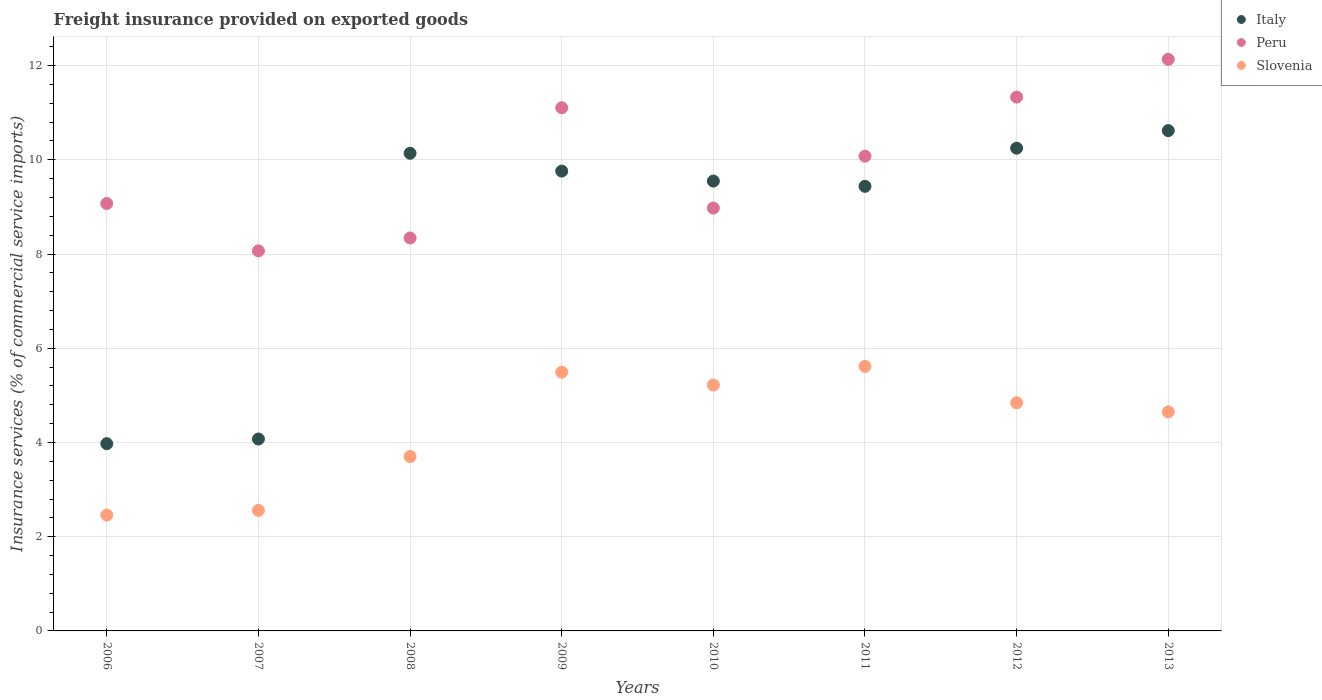Is the number of dotlines equal to the number of legend labels?
Your response must be concise. Yes. What is the freight insurance provided on exported goods in Slovenia in 2011?
Ensure brevity in your answer.  5.61. Across all years, what is the maximum freight insurance provided on exported goods in Slovenia?
Provide a short and direct response. 5.61. Across all years, what is the minimum freight insurance provided on exported goods in Italy?
Give a very brief answer. 3.97. What is the total freight insurance provided on exported goods in Peru in the graph?
Keep it short and to the point. 79.1. What is the difference between the freight insurance provided on exported goods in Italy in 2006 and that in 2009?
Make the answer very short. -5.79. What is the difference between the freight insurance provided on exported goods in Peru in 2006 and the freight insurance provided on exported goods in Italy in 2008?
Your answer should be very brief. -1.07. What is the average freight insurance provided on exported goods in Italy per year?
Provide a succinct answer. 8.47. In the year 2009, what is the difference between the freight insurance provided on exported goods in Peru and freight insurance provided on exported goods in Slovenia?
Give a very brief answer. 5.61. What is the ratio of the freight insurance provided on exported goods in Italy in 2008 to that in 2009?
Your answer should be compact. 1.04. Is the difference between the freight insurance provided on exported goods in Peru in 2008 and 2009 greater than the difference between the freight insurance provided on exported goods in Slovenia in 2008 and 2009?
Make the answer very short. No. What is the difference between the highest and the second highest freight insurance provided on exported goods in Peru?
Keep it short and to the point. 0.8. What is the difference between the highest and the lowest freight insurance provided on exported goods in Slovenia?
Make the answer very short. 3.16. Is the sum of the freight insurance provided on exported goods in Peru in 2008 and 2012 greater than the maximum freight insurance provided on exported goods in Italy across all years?
Keep it short and to the point. Yes. Does the freight insurance provided on exported goods in Slovenia monotonically increase over the years?
Your answer should be very brief. No. What is the difference between two consecutive major ticks on the Y-axis?
Make the answer very short. 2. Are the values on the major ticks of Y-axis written in scientific E-notation?
Provide a short and direct response. No. Does the graph contain any zero values?
Offer a terse response. No. Where does the legend appear in the graph?
Provide a short and direct response. Top right. How many legend labels are there?
Offer a very short reply. 3. What is the title of the graph?
Offer a very short reply. Freight insurance provided on exported goods. What is the label or title of the Y-axis?
Your answer should be very brief. Insurance services (% of commercial service imports). What is the Insurance services (% of commercial service imports) of Italy in 2006?
Make the answer very short. 3.97. What is the Insurance services (% of commercial service imports) of Peru in 2006?
Keep it short and to the point. 9.07. What is the Insurance services (% of commercial service imports) in Slovenia in 2006?
Give a very brief answer. 2.46. What is the Insurance services (% of commercial service imports) of Italy in 2007?
Your response must be concise. 4.07. What is the Insurance services (% of commercial service imports) in Peru in 2007?
Make the answer very short. 8.07. What is the Insurance services (% of commercial service imports) in Slovenia in 2007?
Offer a terse response. 2.56. What is the Insurance services (% of commercial service imports) of Italy in 2008?
Ensure brevity in your answer.  10.14. What is the Insurance services (% of commercial service imports) in Peru in 2008?
Make the answer very short. 8.34. What is the Insurance services (% of commercial service imports) of Slovenia in 2008?
Your answer should be compact. 3.7. What is the Insurance services (% of commercial service imports) in Italy in 2009?
Keep it short and to the point. 9.76. What is the Insurance services (% of commercial service imports) in Peru in 2009?
Keep it short and to the point. 11.1. What is the Insurance services (% of commercial service imports) in Slovenia in 2009?
Your answer should be very brief. 5.49. What is the Insurance services (% of commercial service imports) in Italy in 2010?
Your response must be concise. 9.55. What is the Insurance services (% of commercial service imports) of Peru in 2010?
Your response must be concise. 8.98. What is the Insurance services (% of commercial service imports) in Slovenia in 2010?
Provide a succinct answer. 5.22. What is the Insurance services (% of commercial service imports) in Italy in 2011?
Ensure brevity in your answer.  9.44. What is the Insurance services (% of commercial service imports) of Peru in 2011?
Offer a very short reply. 10.08. What is the Insurance services (% of commercial service imports) of Slovenia in 2011?
Keep it short and to the point. 5.61. What is the Insurance services (% of commercial service imports) of Italy in 2012?
Ensure brevity in your answer.  10.25. What is the Insurance services (% of commercial service imports) of Peru in 2012?
Offer a terse response. 11.33. What is the Insurance services (% of commercial service imports) of Slovenia in 2012?
Your answer should be compact. 4.84. What is the Insurance services (% of commercial service imports) of Italy in 2013?
Your answer should be compact. 10.62. What is the Insurance services (% of commercial service imports) of Peru in 2013?
Your response must be concise. 12.13. What is the Insurance services (% of commercial service imports) in Slovenia in 2013?
Your answer should be compact. 4.65. Across all years, what is the maximum Insurance services (% of commercial service imports) of Italy?
Your answer should be very brief. 10.62. Across all years, what is the maximum Insurance services (% of commercial service imports) in Peru?
Your response must be concise. 12.13. Across all years, what is the maximum Insurance services (% of commercial service imports) of Slovenia?
Provide a short and direct response. 5.61. Across all years, what is the minimum Insurance services (% of commercial service imports) of Italy?
Your response must be concise. 3.97. Across all years, what is the minimum Insurance services (% of commercial service imports) in Peru?
Give a very brief answer. 8.07. Across all years, what is the minimum Insurance services (% of commercial service imports) of Slovenia?
Provide a succinct answer. 2.46. What is the total Insurance services (% of commercial service imports) of Italy in the graph?
Offer a terse response. 67.8. What is the total Insurance services (% of commercial service imports) of Peru in the graph?
Ensure brevity in your answer.  79.1. What is the total Insurance services (% of commercial service imports) of Slovenia in the graph?
Your answer should be compact. 34.54. What is the difference between the Insurance services (% of commercial service imports) in Italy in 2006 and that in 2007?
Your answer should be compact. -0.1. What is the difference between the Insurance services (% of commercial service imports) in Peru in 2006 and that in 2007?
Your response must be concise. 1.01. What is the difference between the Insurance services (% of commercial service imports) in Slovenia in 2006 and that in 2007?
Your answer should be very brief. -0.1. What is the difference between the Insurance services (% of commercial service imports) of Italy in 2006 and that in 2008?
Ensure brevity in your answer.  -6.16. What is the difference between the Insurance services (% of commercial service imports) in Peru in 2006 and that in 2008?
Your answer should be compact. 0.73. What is the difference between the Insurance services (% of commercial service imports) of Slovenia in 2006 and that in 2008?
Your response must be concise. -1.24. What is the difference between the Insurance services (% of commercial service imports) in Italy in 2006 and that in 2009?
Provide a short and direct response. -5.79. What is the difference between the Insurance services (% of commercial service imports) in Peru in 2006 and that in 2009?
Give a very brief answer. -2.03. What is the difference between the Insurance services (% of commercial service imports) in Slovenia in 2006 and that in 2009?
Provide a short and direct response. -3.03. What is the difference between the Insurance services (% of commercial service imports) in Italy in 2006 and that in 2010?
Ensure brevity in your answer.  -5.57. What is the difference between the Insurance services (% of commercial service imports) in Peru in 2006 and that in 2010?
Provide a succinct answer. 0.1. What is the difference between the Insurance services (% of commercial service imports) in Slovenia in 2006 and that in 2010?
Your answer should be compact. -2.76. What is the difference between the Insurance services (% of commercial service imports) in Italy in 2006 and that in 2011?
Your answer should be compact. -5.46. What is the difference between the Insurance services (% of commercial service imports) of Peru in 2006 and that in 2011?
Provide a short and direct response. -1. What is the difference between the Insurance services (% of commercial service imports) of Slovenia in 2006 and that in 2011?
Ensure brevity in your answer.  -3.16. What is the difference between the Insurance services (% of commercial service imports) in Italy in 2006 and that in 2012?
Offer a terse response. -6.27. What is the difference between the Insurance services (% of commercial service imports) in Peru in 2006 and that in 2012?
Your answer should be very brief. -2.26. What is the difference between the Insurance services (% of commercial service imports) of Slovenia in 2006 and that in 2012?
Ensure brevity in your answer.  -2.38. What is the difference between the Insurance services (% of commercial service imports) of Italy in 2006 and that in 2013?
Your response must be concise. -6.65. What is the difference between the Insurance services (% of commercial service imports) in Peru in 2006 and that in 2013?
Make the answer very short. -3.06. What is the difference between the Insurance services (% of commercial service imports) in Slovenia in 2006 and that in 2013?
Your answer should be compact. -2.19. What is the difference between the Insurance services (% of commercial service imports) of Italy in 2007 and that in 2008?
Ensure brevity in your answer.  -6.07. What is the difference between the Insurance services (% of commercial service imports) of Peru in 2007 and that in 2008?
Your response must be concise. -0.27. What is the difference between the Insurance services (% of commercial service imports) of Slovenia in 2007 and that in 2008?
Your response must be concise. -1.14. What is the difference between the Insurance services (% of commercial service imports) in Italy in 2007 and that in 2009?
Make the answer very short. -5.69. What is the difference between the Insurance services (% of commercial service imports) of Peru in 2007 and that in 2009?
Your answer should be very brief. -3.04. What is the difference between the Insurance services (% of commercial service imports) of Slovenia in 2007 and that in 2009?
Your answer should be very brief. -2.93. What is the difference between the Insurance services (% of commercial service imports) of Italy in 2007 and that in 2010?
Make the answer very short. -5.48. What is the difference between the Insurance services (% of commercial service imports) of Peru in 2007 and that in 2010?
Provide a succinct answer. -0.91. What is the difference between the Insurance services (% of commercial service imports) in Slovenia in 2007 and that in 2010?
Provide a succinct answer. -2.66. What is the difference between the Insurance services (% of commercial service imports) in Italy in 2007 and that in 2011?
Your answer should be very brief. -5.36. What is the difference between the Insurance services (% of commercial service imports) of Peru in 2007 and that in 2011?
Keep it short and to the point. -2.01. What is the difference between the Insurance services (% of commercial service imports) of Slovenia in 2007 and that in 2011?
Your response must be concise. -3.05. What is the difference between the Insurance services (% of commercial service imports) of Italy in 2007 and that in 2012?
Keep it short and to the point. -6.17. What is the difference between the Insurance services (% of commercial service imports) in Peru in 2007 and that in 2012?
Your answer should be very brief. -3.26. What is the difference between the Insurance services (% of commercial service imports) of Slovenia in 2007 and that in 2012?
Provide a succinct answer. -2.28. What is the difference between the Insurance services (% of commercial service imports) in Italy in 2007 and that in 2013?
Provide a short and direct response. -6.55. What is the difference between the Insurance services (% of commercial service imports) in Peru in 2007 and that in 2013?
Keep it short and to the point. -4.07. What is the difference between the Insurance services (% of commercial service imports) of Slovenia in 2007 and that in 2013?
Make the answer very short. -2.09. What is the difference between the Insurance services (% of commercial service imports) in Italy in 2008 and that in 2009?
Make the answer very short. 0.38. What is the difference between the Insurance services (% of commercial service imports) in Peru in 2008 and that in 2009?
Provide a succinct answer. -2.76. What is the difference between the Insurance services (% of commercial service imports) of Slovenia in 2008 and that in 2009?
Provide a succinct answer. -1.79. What is the difference between the Insurance services (% of commercial service imports) of Italy in 2008 and that in 2010?
Ensure brevity in your answer.  0.59. What is the difference between the Insurance services (% of commercial service imports) of Peru in 2008 and that in 2010?
Ensure brevity in your answer.  -0.63. What is the difference between the Insurance services (% of commercial service imports) of Slovenia in 2008 and that in 2010?
Provide a short and direct response. -1.52. What is the difference between the Insurance services (% of commercial service imports) in Italy in 2008 and that in 2011?
Ensure brevity in your answer.  0.7. What is the difference between the Insurance services (% of commercial service imports) in Peru in 2008 and that in 2011?
Make the answer very short. -1.74. What is the difference between the Insurance services (% of commercial service imports) of Slovenia in 2008 and that in 2011?
Your response must be concise. -1.91. What is the difference between the Insurance services (% of commercial service imports) of Italy in 2008 and that in 2012?
Provide a succinct answer. -0.11. What is the difference between the Insurance services (% of commercial service imports) in Peru in 2008 and that in 2012?
Provide a succinct answer. -2.99. What is the difference between the Insurance services (% of commercial service imports) of Slovenia in 2008 and that in 2012?
Your response must be concise. -1.14. What is the difference between the Insurance services (% of commercial service imports) in Italy in 2008 and that in 2013?
Your response must be concise. -0.48. What is the difference between the Insurance services (% of commercial service imports) of Peru in 2008 and that in 2013?
Offer a very short reply. -3.79. What is the difference between the Insurance services (% of commercial service imports) of Slovenia in 2008 and that in 2013?
Offer a very short reply. -0.95. What is the difference between the Insurance services (% of commercial service imports) of Italy in 2009 and that in 2010?
Ensure brevity in your answer.  0.21. What is the difference between the Insurance services (% of commercial service imports) of Peru in 2009 and that in 2010?
Your answer should be very brief. 2.13. What is the difference between the Insurance services (% of commercial service imports) in Slovenia in 2009 and that in 2010?
Offer a very short reply. 0.27. What is the difference between the Insurance services (% of commercial service imports) in Italy in 2009 and that in 2011?
Make the answer very short. 0.32. What is the difference between the Insurance services (% of commercial service imports) in Peru in 2009 and that in 2011?
Ensure brevity in your answer.  1.03. What is the difference between the Insurance services (% of commercial service imports) in Slovenia in 2009 and that in 2011?
Your answer should be compact. -0.12. What is the difference between the Insurance services (% of commercial service imports) of Italy in 2009 and that in 2012?
Give a very brief answer. -0.49. What is the difference between the Insurance services (% of commercial service imports) in Peru in 2009 and that in 2012?
Your answer should be very brief. -0.23. What is the difference between the Insurance services (% of commercial service imports) in Slovenia in 2009 and that in 2012?
Your response must be concise. 0.65. What is the difference between the Insurance services (% of commercial service imports) of Italy in 2009 and that in 2013?
Keep it short and to the point. -0.86. What is the difference between the Insurance services (% of commercial service imports) of Peru in 2009 and that in 2013?
Your answer should be compact. -1.03. What is the difference between the Insurance services (% of commercial service imports) in Slovenia in 2009 and that in 2013?
Make the answer very short. 0.84. What is the difference between the Insurance services (% of commercial service imports) in Italy in 2010 and that in 2011?
Provide a succinct answer. 0.11. What is the difference between the Insurance services (% of commercial service imports) in Peru in 2010 and that in 2011?
Provide a succinct answer. -1.1. What is the difference between the Insurance services (% of commercial service imports) in Slovenia in 2010 and that in 2011?
Offer a terse response. -0.4. What is the difference between the Insurance services (% of commercial service imports) of Italy in 2010 and that in 2012?
Give a very brief answer. -0.7. What is the difference between the Insurance services (% of commercial service imports) of Peru in 2010 and that in 2012?
Provide a succinct answer. -2.36. What is the difference between the Insurance services (% of commercial service imports) of Slovenia in 2010 and that in 2012?
Offer a very short reply. 0.37. What is the difference between the Insurance services (% of commercial service imports) of Italy in 2010 and that in 2013?
Keep it short and to the point. -1.07. What is the difference between the Insurance services (% of commercial service imports) of Peru in 2010 and that in 2013?
Your answer should be very brief. -3.16. What is the difference between the Insurance services (% of commercial service imports) in Slovenia in 2010 and that in 2013?
Provide a succinct answer. 0.57. What is the difference between the Insurance services (% of commercial service imports) in Italy in 2011 and that in 2012?
Keep it short and to the point. -0.81. What is the difference between the Insurance services (% of commercial service imports) in Peru in 2011 and that in 2012?
Provide a succinct answer. -1.25. What is the difference between the Insurance services (% of commercial service imports) in Slovenia in 2011 and that in 2012?
Provide a succinct answer. 0.77. What is the difference between the Insurance services (% of commercial service imports) in Italy in 2011 and that in 2013?
Make the answer very short. -1.18. What is the difference between the Insurance services (% of commercial service imports) in Peru in 2011 and that in 2013?
Ensure brevity in your answer.  -2.06. What is the difference between the Insurance services (% of commercial service imports) of Slovenia in 2011 and that in 2013?
Ensure brevity in your answer.  0.96. What is the difference between the Insurance services (% of commercial service imports) in Italy in 2012 and that in 2013?
Provide a succinct answer. -0.37. What is the difference between the Insurance services (% of commercial service imports) in Peru in 2012 and that in 2013?
Your answer should be very brief. -0.8. What is the difference between the Insurance services (% of commercial service imports) of Slovenia in 2012 and that in 2013?
Offer a very short reply. 0.19. What is the difference between the Insurance services (% of commercial service imports) in Italy in 2006 and the Insurance services (% of commercial service imports) in Peru in 2007?
Make the answer very short. -4.09. What is the difference between the Insurance services (% of commercial service imports) of Italy in 2006 and the Insurance services (% of commercial service imports) of Slovenia in 2007?
Offer a very short reply. 1.41. What is the difference between the Insurance services (% of commercial service imports) in Peru in 2006 and the Insurance services (% of commercial service imports) in Slovenia in 2007?
Provide a succinct answer. 6.51. What is the difference between the Insurance services (% of commercial service imports) of Italy in 2006 and the Insurance services (% of commercial service imports) of Peru in 2008?
Offer a very short reply. -4.37. What is the difference between the Insurance services (% of commercial service imports) in Italy in 2006 and the Insurance services (% of commercial service imports) in Slovenia in 2008?
Give a very brief answer. 0.27. What is the difference between the Insurance services (% of commercial service imports) in Peru in 2006 and the Insurance services (% of commercial service imports) in Slovenia in 2008?
Your answer should be very brief. 5.37. What is the difference between the Insurance services (% of commercial service imports) in Italy in 2006 and the Insurance services (% of commercial service imports) in Peru in 2009?
Offer a terse response. -7.13. What is the difference between the Insurance services (% of commercial service imports) of Italy in 2006 and the Insurance services (% of commercial service imports) of Slovenia in 2009?
Your response must be concise. -1.52. What is the difference between the Insurance services (% of commercial service imports) in Peru in 2006 and the Insurance services (% of commercial service imports) in Slovenia in 2009?
Your answer should be compact. 3.58. What is the difference between the Insurance services (% of commercial service imports) of Italy in 2006 and the Insurance services (% of commercial service imports) of Peru in 2010?
Keep it short and to the point. -5. What is the difference between the Insurance services (% of commercial service imports) in Italy in 2006 and the Insurance services (% of commercial service imports) in Slovenia in 2010?
Ensure brevity in your answer.  -1.24. What is the difference between the Insurance services (% of commercial service imports) in Peru in 2006 and the Insurance services (% of commercial service imports) in Slovenia in 2010?
Your response must be concise. 3.85. What is the difference between the Insurance services (% of commercial service imports) of Italy in 2006 and the Insurance services (% of commercial service imports) of Peru in 2011?
Give a very brief answer. -6.1. What is the difference between the Insurance services (% of commercial service imports) of Italy in 2006 and the Insurance services (% of commercial service imports) of Slovenia in 2011?
Keep it short and to the point. -1.64. What is the difference between the Insurance services (% of commercial service imports) of Peru in 2006 and the Insurance services (% of commercial service imports) of Slovenia in 2011?
Provide a short and direct response. 3.46. What is the difference between the Insurance services (% of commercial service imports) in Italy in 2006 and the Insurance services (% of commercial service imports) in Peru in 2012?
Your response must be concise. -7.36. What is the difference between the Insurance services (% of commercial service imports) in Italy in 2006 and the Insurance services (% of commercial service imports) in Slovenia in 2012?
Keep it short and to the point. -0.87. What is the difference between the Insurance services (% of commercial service imports) in Peru in 2006 and the Insurance services (% of commercial service imports) in Slovenia in 2012?
Give a very brief answer. 4.23. What is the difference between the Insurance services (% of commercial service imports) of Italy in 2006 and the Insurance services (% of commercial service imports) of Peru in 2013?
Keep it short and to the point. -8.16. What is the difference between the Insurance services (% of commercial service imports) in Italy in 2006 and the Insurance services (% of commercial service imports) in Slovenia in 2013?
Provide a short and direct response. -0.68. What is the difference between the Insurance services (% of commercial service imports) in Peru in 2006 and the Insurance services (% of commercial service imports) in Slovenia in 2013?
Your answer should be compact. 4.42. What is the difference between the Insurance services (% of commercial service imports) of Italy in 2007 and the Insurance services (% of commercial service imports) of Peru in 2008?
Your answer should be very brief. -4.27. What is the difference between the Insurance services (% of commercial service imports) of Italy in 2007 and the Insurance services (% of commercial service imports) of Slovenia in 2008?
Your answer should be compact. 0.37. What is the difference between the Insurance services (% of commercial service imports) of Peru in 2007 and the Insurance services (% of commercial service imports) of Slovenia in 2008?
Offer a terse response. 4.37. What is the difference between the Insurance services (% of commercial service imports) of Italy in 2007 and the Insurance services (% of commercial service imports) of Peru in 2009?
Offer a very short reply. -7.03. What is the difference between the Insurance services (% of commercial service imports) of Italy in 2007 and the Insurance services (% of commercial service imports) of Slovenia in 2009?
Give a very brief answer. -1.42. What is the difference between the Insurance services (% of commercial service imports) of Peru in 2007 and the Insurance services (% of commercial service imports) of Slovenia in 2009?
Your answer should be compact. 2.57. What is the difference between the Insurance services (% of commercial service imports) of Italy in 2007 and the Insurance services (% of commercial service imports) of Peru in 2010?
Offer a terse response. -4.9. What is the difference between the Insurance services (% of commercial service imports) in Italy in 2007 and the Insurance services (% of commercial service imports) in Slovenia in 2010?
Provide a succinct answer. -1.15. What is the difference between the Insurance services (% of commercial service imports) in Peru in 2007 and the Insurance services (% of commercial service imports) in Slovenia in 2010?
Make the answer very short. 2.85. What is the difference between the Insurance services (% of commercial service imports) in Italy in 2007 and the Insurance services (% of commercial service imports) in Peru in 2011?
Give a very brief answer. -6. What is the difference between the Insurance services (% of commercial service imports) in Italy in 2007 and the Insurance services (% of commercial service imports) in Slovenia in 2011?
Give a very brief answer. -1.54. What is the difference between the Insurance services (% of commercial service imports) in Peru in 2007 and the Insurance services (% of commercial service imports) in Slovenia in 2011?
Ensure brevity in your answer.  2.45. What is the difference between the Insurance services (% of commercial service imports) in Italy in 2007 and the Insurance services (% of commercial service imports) in Peru in 2012?
Give a very brief answer. -7.26. What is the difference between the Insurance services (% of commercial service imports) of Italy in 2007 and the Insurance services (% of commercial service imports) of Slovenia in 2012?
Provide a short and direct response. -0.77. What is the difference between the Insurance services (% of commercial service imports) in Peru in 2007 and the Insurance services (% of commercial service imports) in Slovenia in 2012?
Provide a short and direct response. 3.22. What is the difference between the Insurance services (% of commercial service imports) in Italy in 2007 and the Insurance services (% of commercial service imports) in Peru in 2013?
Your answer should be compact. -8.06. What is the difference between the Insurance services (% of commercial service imports) of Italy in 2007 and the Insurance services (% of commercial service imports) of Slovenia in 2013?
Your answer should be compact. -0.58. What is the difference between the Insurance services (% of commercial service imports) of Peru in 2007 and the Insurance services (% of commercial service imports) of Slovenia in 2013?
Your answer should be very brief. 3.42. What is the difference between the Insurance services (% of commercial service imports) of Italy in 2008 and the Insurance services (% of commercial service imports) of Peru in 2009?
Keep it short and to the point. -0.97. What is the difference between the Insurance services (% of commercial service imports) in Italy in 2008 and the Insurance services (% of commercial service imports) in Slovenia in 2009?
Provide a short and direct response. 4.65. What is the difference between the Insurance services (% of commercial service imports) of Peru in 2008 and the Insurance services (% of commercial service imports) of Slovenia in 2009?
Keep it short and to the point. 2.85. What is the difference between the Insurance services (% of commercial service imports) in Italy in 2008 and the Insurance services (% of commercial service imports) in Peru in 2010?
Give a very brief answer. 1.16. What is the difference between the Insurance services (% of commercial service imports) in Italy in 2008 and the Insurance services (% of commercial service imports) in Slovenia in 2010?
Your answer should be very brief. 4.92. What is the difference between the Insurance services (% of commercial service imports) of Peru in 2008 and the Insurance services (% of commercial service imports) of Slovenia in 2010?
Keep it short and to the point. 3.12. What is the difference between the Insurance services (% of commercial service imports) of Italy in 2008 and the Insurance services (% of commercial service imports) of Peru in 2011?
Provide a succinct answer. 0.06. What is the difference between the Insurance services (% of commercial service imports) of Italy in 2008 and the Insurance services (% of commercial service imports) of Slovenia in 2011?
Offer a very short reply. 4.52. What is the difference between the Insurance services (% of commercial service imports) in Peru in 2008 and the Insurance services (% of commercial service imports) in Slovenia in 2011?
Make the answer very short. 2.73. What is the difference between the Insurance services (% of commercial service imports) of Italy in 2008 and the Insurance services (% of commercial service imports) of Peru in 2012?
Give a very brief answer. -1.19. What is the difference between the Insurance services (% of commercial service imports) of Italy in 2008 and the Insurance services (% of commercial service imports) of Slovenia in 2012?
Provide a succinct answer. 5.29. What is the difference between the Insurance services (% of commercial service imports) of Peru in 2008 and the Insurance services (% of commercial service imports) of Slovenia in 2012?
Offer a terse response. 3.5. What is the difference between the Insurance services (% of commercial service imports) of Italy in 2008 and the Insurance services (% of commercial service imports) of Peru in 2013?
Make the answer very short. -1.99. What is the difference between the Insurance services (% of commercial service imports) in Italy in 2008 and the Insurance services (% of commercial service imports) in Slovenia in 2013?
Ensure brevity in your answer.  5.49. What is the difference between the Insurance services (% of commercial service imports) in Peru in 2008 and the Insurance services (% of commercial service imports) in Slovenia in 2013?
Make the answer very short. 3.69. What is the difference between the Insurance services (% of commercial service imports) in Italy in 2009 and the Insurance services (% of commercial service imports) in Peru in 2010?
Offer a terse response. 0.78. What is the difference between the Insurance services (% of commercial service imports) of Italy in 2009 and the Insurance services (% of commercial service imports) of Slovenia in 2010?
Ensure brevity in your answer.  4.54. What is the difference between the Insurance services (% of commercial service imports) in Peru in 2009 and the Insurance services (% of commercial service imports) in Slovenia in 2010?
Keep it short and to the point. 5.89. What is the difference between the Insurance services (% of commercial service imports) in Italy in 2009 and the Insurance services (% of commercial service imports) in Peru in 2011?
Offer a very short reply. -0.32. What is the difference between the Insurance services (% of commercial service imports) of Italy in 2009 and the Insurance services (% of commercial service imports) of Slovenia in 2011?
Your response must be concise. 4.15. What is the difference between the Insurance services (% of commercial service imports) of Peru in 2009 and the Insurance services (% of commercial service imports) of Slovenia in 2011?
Offer a terse response. 5.49. What is the difference between the Insurance services (% of commercial service imports) in Italy in 2009 and the Insurance services (% of commercial service imports) in Peru in 2012?
Ensure brevity in your answer.  -1.57. What is the difference between the Insurance services (% of commercial service imports) of Italy in 2009 and the Insurance services (% of commercial service imports) of Slovenia in 2012?
Make the answer very short. 4.92. What is the difference between the Insurance services (% of commercial service imports) of Peru in 2009 and the Insurance services (% of commercial service imports) of Slovenia in 2012?
Provide a short and direct response. 6.26. What is the difference between the Insurance services (% of commercial service imports) of Italy in 2009 and the Insurance services (% of commercial service imports) of Peru in 2013?
Ensure brevity in your answer.  -2.37. What is the difference between the Insurance services (% of commercial service imports) of Italy in 2009 and the Insurance services (% of commercial service imports) of Slovenia in 2013?
Make the answer very short. 5.11. What is the difference between the Insurance services (% of commercial service imports) in Peru in 2009 and the Insurance services (% of commercial service imports) in Slovenia in 2013?
Give a very brief answer. 6.45. What is the difference between the Insurance services (% of commercial service imports) of Italy in 2010 and the Insurance services (% of commercial service imports) of Peru in 2011?
Your answer should be very brief. -0.53. What is the difference between the Insurance services (% of commercial service imports) in Italy in 2010 and the Insurance services (% of commercial service imports) in Slovenia in 2011?
Offer a terse response. 3.93. What is the difference between the Insurance services (% of commercial service imports) in Peru in 2010 and the Insurance services (% of commercial service imports) in Slovenia in 2011?
Make the answer very short. 3.36. What is the difference between the Insurance services (% of commercial service imports) of Italy in 2010 and the Insurance services (% of commercial service imports) of Peru in 2012?
Offer a terse response. -1.78. What is the difference between the Insurance services (% of commercial service imports) in Italy in 2010 and the Insurance services (% of commercial service imports) in Slovenia in 2012?
Give a very brief answer. 4.71. What is the difference between the Insurance services (% of commercial service imports) in Peru in 2010 and the Insurance services (% of commercial service imports) in Slovenia in 2012?
Keep it short and to the point. 4.13. What is the difference between the Insurance services (% of commercial service imports) in Italy in 2010 and the Insurance services (% of commercial service imports) in Peru in 2013?
Keep it short and to the point. -2.58. What is the difference between the Insurance services (% of commercial service imports) in Italy in 2010 and the Insurance services (% of commercial service imports) in Slovenia in 2013?
Your response must be concise. 4.9. What is the difference between the Insurance services (% of commercial service imports) of Peru in 2010 and the Insurance services (% of commercial service imports) of Slovenia in 2013?
Your response must be concise. 4.32. What is the difference between the Insurance services (% of commercial service imports) of Italy in 2011 and the Insurance services (% of commercial service imports) of Peru in 2012?
Give a very brief answer. -1.89. What is the difference between the Insurance services (% of commercial service imports) in Italy in 2011 and the Insurance services (% of commercial service imports) in Slovenia in 2012?
Provide a short and direct response. 4.59. What is the difference between the Insurance services (% of commercial service imports) in Peru in 2011 and the Insurance services (% of commercial service imports) in Slovenia in 2012?
Your response must be concise. 5.23. What is the difference between the Insurance services (% of commercial service imports) of Italy in 2011 and the Insurance services (% of commercial service imports) of Peru in 2013?
Your answer should be very brief. -2.69. What is the difference between the Insurance services (% of commercial service imports) in Italy in 2011 and the Insurance services (% of commercial service imports) in Slovenia in 2013?
Offer a terse response. 4.79. What is the difference between the Insurance services (% of commercial service imports) of Peru in 2011 and the Insurance services (% of commercial service imports) of Slovenia in 2013?
Provide a short and direct response. 5.42. What is the difference between the Insurance services (% of commercial service imports) in Italy in 2012 and the Insurance services (% of commercial service imports) in Peru in 2013?
Ensure brevity in your answer.  -1.89. What is the difference between the Insurance services (% of commercial service imports) of Italy in 2012 and the Insurance services (% of commercial service imports) of Slovenia in 2013?
Keep it short and to the point. 5.6. What is the difference between the Insurance services (% of commercial service imports) in Peru in 2012 and the Insurance services (% of commercial service imports) in Slovenia in 2013?
Your response must be concise. 6.68. What is the average Insurance services (% of commercial service imports) of Italy per year?
Offer a very short reply. 8.47. What is the average Insurance services (% of commercial service imports) in Peru per year?
Offer a terse response. 9.89. What is the average Insurance services (% of commercial service imports) in Slovenia per year?
Make the answer very short. 4.32. In the year 2006, what is the difference between the Insurance services (% of commercial service imports) in Italy and Insurance services (% of commercial service imports) in Peru?
Your response must be concise. -5.1. In the year 2006, what is the difference between the Insurance services (% of commercial service imports) of Italy and Insurance services (% of commercial service imports) of Slovenia?
Provide a succinct answer. 1.51. In the year 2006, what is the difference between the Insurance services (% of commercial service imports) in Peru and Insurance services (% of commercial service imports) in Slovenia?
Make the answer very short. 6.61. In the year 2007, what is the difference between the Insurance services (% of commercial service imports) in Italy and Insurance services (% of commercial service imports) in Peru?
Keep it short and to the point. -3.99. In the year 2007, what is the difference between the Insurance services (% of commercial service imports) in Italy and Insurance services (% of commercial service imports) in Slovenia?
Your answer should be very brief. 1.51. In the year 2007, what is the difference between the Insurance services (% of commercial service imports) of Peru and Insurance services (% of commercial service imports) of Slovenia?
Provide a short and direct response. 5.51. In the year 2008, what is the difference between the Insurance services (% of commercial service imports) in Italy and Insurance services (% of commercial service imports) in Peru?
Your answer should be compact. 1.8. In the year 2008, what is the difference between the Insurance services (% of commercial service imports) of Italy and Insurance services (% of commercial service imports) of Slovenia?
Keep it short and to the point. 6.44. In the year 2008, what is the difference between the Insurance services (% of commercial service imports) of Peru and Insurance services (% of commercial service imports) of Slovenia?
Make the answer very short. 4.64. In the year 2009, what is the difference between the Insurance services (% of commercial service imports) of Italy and Insurance services (% of commercial service imports) of Peru?
Offer a terse response. -1.35. In the year 2009, what is the difference between the Insurance services (% of commercial service imports) of Italy and Insurance services (% of commercial service imports) of Slovenia?
Ensure brevity in your answer.  4.27. In the year 2009, what is the difference between the Insurance services (% of commercial service imports) in Peru and Insurance services (% of commercial service imports) in Slovenia?
Provide a short and direct response. 5.61. In the year 2010, what is the difference between the Insurance services (% of commercial service imports) of Italy and Insurance services (% of commercial service imports) of Peru?
Offer a terse response. 0.57. In the year 2010, what is the difference between the Insurance services (% of commercial service imports) of Italy and Insurance services (% of commercial service imports) of Slovenia?
Your answer should be compact. 4.33. In the year 2010, what is the difference between the Insurance services (% of commercial service imports) in Peru and Insurance services (% of commercial service imports) in Slovenia?
Give a very brief answer. 3.76. In the year 2011, what is the difference between the Insurance services (% of commercial service imports) of Italy and Insurance services (% of commercial service imports) of Peru?
Provide a short and direct response. -0.64. In the year 2011, what is the difference between the Insurance services (% of commercial service imports) of Italy and Insurance services (% of commercial service imports) of Slovenia?
Your answer should be compact. 3.82. In the year 2011, what is the difference between the Insurance services (% of commercial service imports) in Peru and Insurance services (% of commercial service imports) in Slovenia?
Make the answer very short. 4.46. In the year 2012, what is the difference between the Insurance services (% of commercial service imports) of Italy and Insurance services (% of commercial service imports) of Peru?
Provide a succinct answer. -1.08. In the year 2012, what is the difference between the Insurance services (% of commercial service imports) in Italy and Insurance services (% of commercial service imports) in Slovenia?
Keep it short and to the point. 5.4. In the year 2012, what is the difference between the Insurance services (% of commercial service imports) in Peru and Insurance services (% of commercial service imports) in Slovenia?
Offer a terse response. 6.49. In the year 2013, what is the difference between the Insurance services (% of commercial service imports) of Italy and Insurance services (% of commercial service imports) of Peru?
Ensure brevity in your answer.  -1.51. In the year 2013, what is the difference between the Insurance services (% of commercial service imports) in Italy and Insurance services (% of commercial service imports) in Slovenia?
Provide a short and direct response. 5.97. In the year 2013, what is the difference between the Insurance services (% of commercial service imports) in Peru and Insurance services (% of commercial service imports) in Slovenia?
Keep it short and to the point. 7.48. What is the ratio of the Insurance services (% of commercial service imports) of Italy in 2006 to that in 2007?
Your answer should be very brief. 0.98. What is the ratio of the Insurance services (% of commercial service imports) in Peru in 2006 to that in 2007?
Keep it short and to the point. 1.12. What is the ratio of the Insurance services (% of commercial service imports) of Slovenia in 2006 to that in 2007?
Give a very brief answer. 0.96. What is the ratio of the Insurance services (% of commercial service imports) in Italy in 2006 to that in 2008?
Offer a terse response. 0.39. What is the ratio of the Insurance services (% of commercial service imports) in Peru in 2006 to that in 2008?
Provide a short and direct response. 1.09. What is the ratio of the Insurance services (% of commercial service imports) in Slovenia in 2006 to that in 2008?
Your response must be concise. 0.66. What is the ratio of the Insurance services (% of commercial service imports) of Italy in 2006 to that in 2009?
Offer a terse response. 0.41. What is the ratio of the Insurance services (% of commercial service imports) in Peru in 2006 to that in 2009?
Provide a succinct answer. 0.82. What is the ratio of the Insurance services (% of commercial service imports) in Slovenia in 2006 to that in 2009?
Provide a short and direct response. 0.45. What is the ratio of the Insurance services (% of commercial service imports) of Italy in 2006 to that in 2010?
Your response must be concise. 0.42. What is the ratio of the Insurance services (% of commercial service imports) of Peru in 2006 to that in 2010?
Offer a terse response. 1.01. What is the ratio of the Insurance services (% of commercial service imports) of Slovenia in 2006 to that in 2010?
Make the answer very short. 0.47. What is the ratio of the Insurance services (% of commercial service imports) in Italy in 2006 to that in 2011?
Your answer should be compact. 0.42. What is the ratio of the Insurance services (% of commercial service imports) in Peru in 2006 to that in 2011?
Your answer should be very brief. 0.9. What is the ratio of the Insurance services (% of commercial service imports) in Slovenia in 2006 to that in 2011?
Your answer should be very brief. 0.44. What is the ratio of the Insurance services (% of commercial service imports) in Italy in 2006 to that in 2012?
Ensure brevity in your answer.  0.39. What is the ratio of the Insurance services (% of commercial service imports) in Peru in 2006 to that in 2012?
Offer a terse response. 0.8. What is the ratio of the Insurance services (% of commercial service imports) in Slovenia in 2006 to that in 2012?
Make the answer very short. 0.51. What is the ratio of the Insurance services (% of commercial service imports) in Italy in 2006 to that in 2013?
Give a very brief answer. 0.37. What is the ratio of the Insurance services (% of commercial service imports) of Peru in 2006 to that in 2013?
Your answer should be compact. 0.75. What is the ratio of the Insurance services (% of commercial service imports) in Slovenia in 2006 to that in 2013?
Keep it short and to the point. 0.53. What is the ratio of the Insurance services (% of commercial service imports) in Italy in 2007 to that in 2008?
Ensure brevity in your answer.  0.4. What is the ratio of the Insurance services (% of commercial service imports) in Peru in 2007 to that in 2008?
Offer a terse response. 0.97. What is the ratio of the Insurance services (% of commercial service imports) in Slovenia in 2007 to that in 2008?
Ensure brevity in your answer.  0.69. What is the ratio of the Insurance services (% of commercial service imports) of Italy in 2007 to that in 2009?
Provide a succinct answer. 0.42. What is the ratio of the Insurance services (% of commercial service imports) of Peru in 2007 to that in 2009?
Ensure brevity in your answer.  0.73. What is the ratio of the Insurance services (% of commercial service imports) in Slovenia in 2007 to that in 2009?
Make the answer very short. 0.47. What is the ratio of the Insurance services (% of commercial service imports) of Italy in 2007 to that in 2010?
Offer a very short reply. 0.43. What is the ratio of the Insurance services (% of commercial service imports) of Peru in 2007 to that in 2010?
Provide a succinct answer. 0.9. What is the ratio of the Insurance services (% of commercial service imports) of Slovenia in 2007 to that in 2010?
Provide a succinct answer. 0.49. What is the ratio of the Insurance services (% of commercial service imports) in Italy in 2007 to that in 2011?
Your answer should be very brief. 0.43. What is the ratio of the Insurance services (% of commercial service imports) of Peru in 2007 to that in 2011?
Make the answer very short. 0.8. What is the ratio of the Insurance services (% of commercial service imports) in Slovenia in 2007 to that in 2011?
Your answer should be very brief. 0.46. What is the ratio of the Insurance services (% of commercial service imports) of Italy in 2007 to that in 2012?
Make the answer very short. 0.4. What is the ratio of the Insurance services (% of commercial service imports) of Peru in 2007 to that in 2012?
Give a very brief answer. 0.71. What is the ratio of the Insurance services (% of commercial service imports) of Slovenia in 2007 to that in 2012?
Offer a very short reply. 0.53. What is the ratio of the Insurance services (% of commercial service imports) of Italy in 2007 to that in 2013?
Your answer should be very brief. 0.38. What is the ratio of the Insurance services (% of commercial service imports) of Peru in 2007 to that in 2013?
Offer a very short reply. 0.66. What is the ratio of the Insurance services (% of commercial service imports) in Slovenia in 2007 to that in 2013?
Provide a succinct answer. 0.55. What is the ratio of the Insurance services (% of commercial service imports) in Italy in 2008 to that in 2009?
Give a very brief answer. 1.04. What is the ratio of the Insurance services (% of commercial service imports) of Peru in 2008 to that in 2009?
Offer a very short reply. 0.75. What is the ratio of the Insurance services (% of commercial service imports) in Slovenia in 2008 to that in 2009?
Your response must be concise. 0.67. What is the ratio of the Insurance services (% of commercial service imports) in Italy in 2008 to that in 2010?
Give a very brief answer. 1.06. What is the ratio of the Insurance services (% of commercial service imports) of Peru in 2008 to that in 2010?
Your answer should be compact. 0.93. What is the ratio of the Insurance services (% of commercial service imports) of Slovenia in 2008 to that in 2010?
Offer a terse response. 0.71. What is the ratio of the Insurance services (% of commercial service imports) of Italy in 2008 to that in 2011?
Provide a short and direct response. 1.07. What is the ratio of the Insurance services (% of commercial service imports) in Peru in 2008 to that in 2011?
Your answer should be compact. 0.83. What is the ratio of the Insurance services (% of commercial service imports) in Slovenia in 2008 to that in 2011?
Provide a short and direct response. 0.66. What is the ratio of the Insurance services (% of commercial service imports) of Peru in 2008 to that in 2012?
Offer a terse response. 0.74. What is the ratio of the Insurance services (% of commercial service imports) of Slovenia in 2008 to that in 2012?
Your response must be concise. 0.76. What is the ratio of the Insurance services (% of commercial service imports) in Italy in 2008 to that in 2013?
Ensure brevity in your answer.  0.95. What is the ratio of the Insurance services (% of commercial service imports) in Peru in 2008 to that in 2013?
Offer a very short reply. 0.69. What is the ratio of the Insurance services (% of commercial service imports) in Slovenia in 2008 to that in 2013?
Offer a very short reply. 0.8. What is the ratio of the Insurance services (% of commercial service imports) in Italy in 2009 to that in 2010?
Your answer should be very brief. 1.02. What is the ratio of the Insurance services (% of commercial service imports) in Peru in 2009 to that in 2010?
Offer a terse response. 1.24. What is the ratio of the Insurance services (% of commercial service imports) of Slovenia in 2009 to that in 2010?
Your answer should be very brief. 1.05. What is the ratio of the Insurance services (% of commercial service imports) of Italy in 2009 to that in 2011?
Your answer should be very brief. 1.03. What is the ratio of the Insurance services (% of commercial service imports) of Peru in 2009 to that in 2011?
Offer a terse response. 1.1. What is the ratio of the Insurance services (% of commercial service imports) in Slovenia in 2009 to that in 2011?
Ensure brevity in your answer.  0.98. What is the ratio of the Insurance services (% of commercial service imports) of Italy in 2009 to that in 2012?
Offer a terse response. 0.95. What is the ratio of the Insurance services (% of commercial service imports) of Peru in 2009 to that in 2012?
Ensure brevity in your answer.  0.98. What is the ratio of the Insurance services (% of commercial service imports) in Slovenia in 2009 to that in 2012?
Your response must be concise. 1.13. What is the ratio of the Insurance services (% of commercial service imports) of Italy in 2009 to that in 2013?
Provide a succinct answer. 0.92. What is the ratio of the Insurance services (% of commercial service imports) of Peru in 2009 to that in 2013?
Your answer should be very brief. 0.92. What is the ratio of the Insurance services (% of commercial service imports) of Slovenia in 2009 to that in 2013?
Your answer should be very brief. 1.18. What is the ratio of the Insurance services (% of commercial service imports) in Italy in 2010 to that in 2011?
Provide a short and direct response. 1.01. What is the ratio of the Insurance services (% of commercial service imports) in Peru in 2010 to that in 2011?
Provide a succinct answer. 0.89. What is the ratio of the Insurance services (% of commercial service imports) of Slovenia in 2010 to that in 2011?
Your response must be concise. 0.93. What is the ratio of the Insurance services (% of commercial service imports) of Italy in 2010 to that in 2012?
Give a very brief answer. 0.93. What is the ratio of the Insurance services (% of commercial service imports) of Peru in 2010 to that in 2012?
Give a very brief answer. 0.79. What is the ratio of the Insurance services (% of commercial service imports) of Slovenia in 2010 to that in 2012?
Make the answer very short. 1.08. What is the ratio of the Insurance services (% of commercial service imports) in Italy in 2010 to that in 2013?
Make the answer very short. 0.9. What is the ratio of the Insurance services (% of commercial service imports) of Peru in 2010 to that in 2013?
Offer a very short reply. 0.74. What is the ratio of the Insurance services (% of commercial service imports) in Slovenia in 2010 to that in 2013?
Keep it short and to the point. 1.12. What is the ratio of the Insurance services (% of commercial service imports) in Italy in 2011 to that in 2012?
Provide a short and direct response. 0.92. What is the ratio of the Insurance services (% of commercial service imports) in Peru in 2011 to that in 2012?
Provide a succinct answer. 0.89. What is the ratio of the Insurance services (% of commercial service imports) in Slovenia in 2011 to that in 2012?
Your response must be concise. 1.16. What is the ratio of the Insurance services (% of commercial service imports) of Italy in 2011 to that in 2013?
Give a very brief answer. 0.89. What is the ratio of the Insurance services (% of commercial service imports) of Peru in 2011 to that in 2013?
Your answer should be compact. 0.83. What is the ratio of the Insurance services (% of commercial service imports) in Slovenia in 2011 to that in 2013?
Keep it short and to the point. 1.21. What is the ratio of the Insurance services (% of commercial service imports) of Italy in 2012 to that in 2013?
Offer a very short reply. 0.96. What is the ratio of the Insurance services (% of commercial service imports) in Peru in 2012 to that in 2013?
Offer a terse response. 0.93. What is the ratio of the Insurance services (% of commercial service imports) in Slovenia in 2012 to that in 2013?
Provide a short and direct response. 1.04. What is the difference between the highest and the second highest Insurance services (% of commercial service imports) of Italy?
Your answer should be compact. 0.37. What is the difference between the highest and the second highest Insurance services (% of commercial service imports) in Peru?
Provide a succinct answer. 0.8. What is the difference between the highest and the second highest Insurance services (% of commercial service imports) in Slovenia?
Ensure brevity in your answer.  0.12. What is the difference between the highest and the lowest Insurance services (% of commercial service imports) of Italy?
Provide a short and direct response. 6.65. What is the difference between the highest and the lowest Insurance services (% of commercial service imports) in Peru?
Keep it short and to the point. 4.07. What is the difference between the highest and the lowest Insurance services (% of commercial service imports) in Slovenia?
Offer a terse response. 3.16. 